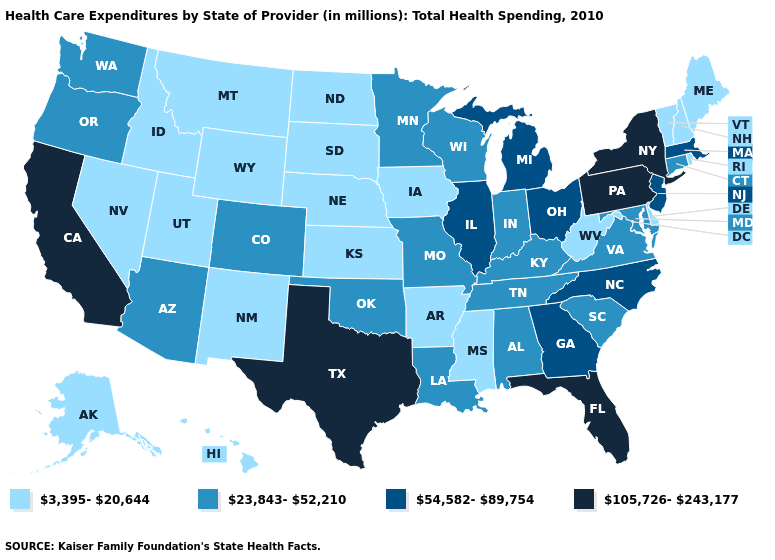Name the states that have a value in the range 105,726-243,177?
Give a very brief answer. California, Florida, New York, Pennsylvania, Texas. Name the states that have a value in the range 3,395-20,644?
Concise answer only. Alaska, Arkansas, Delaware, Hawaii, Idaho, Iowa, Kansas, Maine, Mississippi, Montana, Nebraska, Nevada, New Hampshire, New Mexico, North Dakota, Rhode Island, South Dakota, Utah, Vermont, West Virginia, Wyoming. What is the value of Wyoming?
Short answer required. 3,395-20,644. Which states have the lowest value in the USA?
Answer briefly. Alaska, Arkansas, Delaware, Hawaii, Idaho, Iowa, Kansas, Maine, Mississippi, Montana, Nebraska, Nevada, New Hampshire, New Mexico, North Dakota, Rhode Island, South Dakota, Utah, Vermont, West Virginia, Wyoming. Name the states that have a value in the range 3,395-20,644?
Keep it brief. Alaska, Arkansas, Delaware, Hawaii, Idaho, Iowa, Kansas, Maine, Mississippi, Montana, Nebraska, Nevada, New Hampshire, New Mexico, North Dakota, Rhode Island, South Dakota, Utah, Vermont, West Virginia, Wyoming. Does the first symbol in the legend represent the smallest category?
Be succinct. Yes. Which states have the lowest value in the South?
Be succinct. Arkansas, Delaware, Mississippi, West Virginia. Name the states that have a value in the range 54,582-89,754?
Keep it brief. Georgia, Illinois, Massachusetts, Michigan, New Jersey, North Carolina, Ohio. Name the states that have a value in the range 23,843-52,210?
Quick response, please. Alabama, Arizona, Colorado, Connecticut, Indiana, Kentucky, Louisiana, Maryland, Minnesota, Missouri, Oklahoma, Oregon, South Carolina, Tennessee, Virginia, Washington, Wisconsin. What is the lowest value in the USA?
Quick response, please. 3,395-20,644. Does the map have missing data?
Short answer required. No. Does Arkansas have the lowest value in the South?
Short answer required. Yes. What is the value of Idaho?
Write a very short answer. 3,395-20,644. What is the value of Idaho?
Concise answer only. 3,395-20,644. Among the states that border Pennsylvania , which have the lowest value?
Keep it brief. Delaware, West Virginia. 